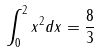Convert formula to latex. <formula><loc_0><loc_0><loc_500><loc_500>\int _ { 0 } ^ { 2 } x ^ { 2 } d x = \frac { 8 } { 3 }</formula> 